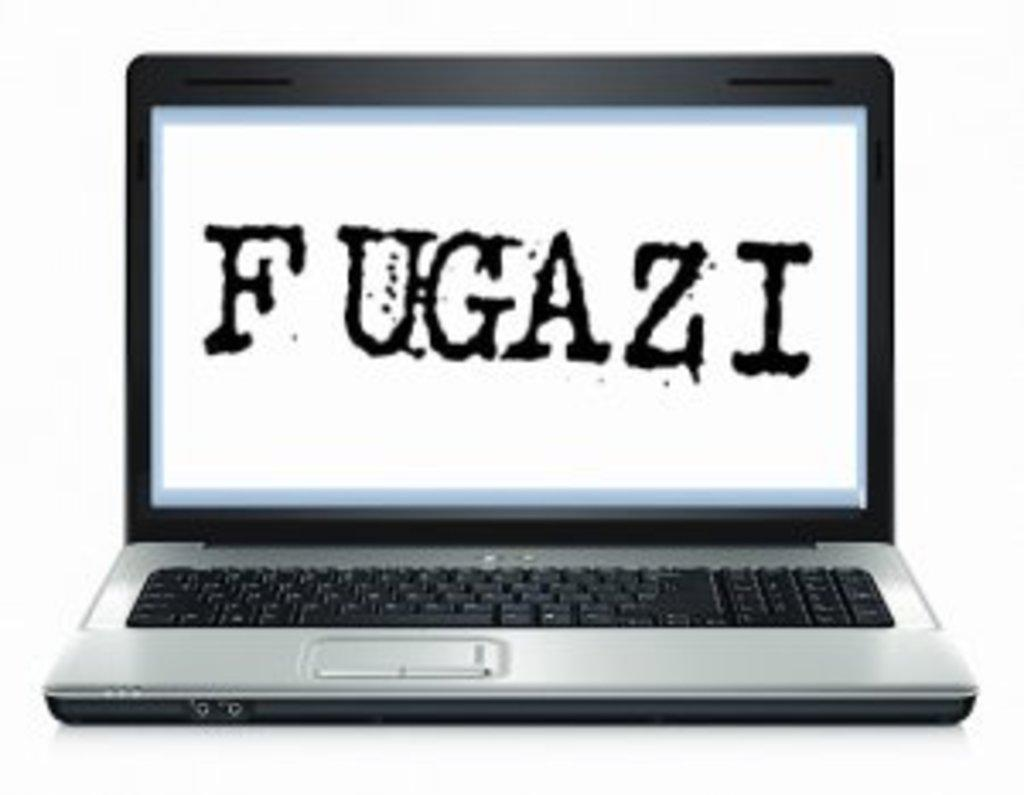<image>
Create a compact narrative representing the image presented. A computer with the word Fugazi on the screen in splatter style text sits open. 